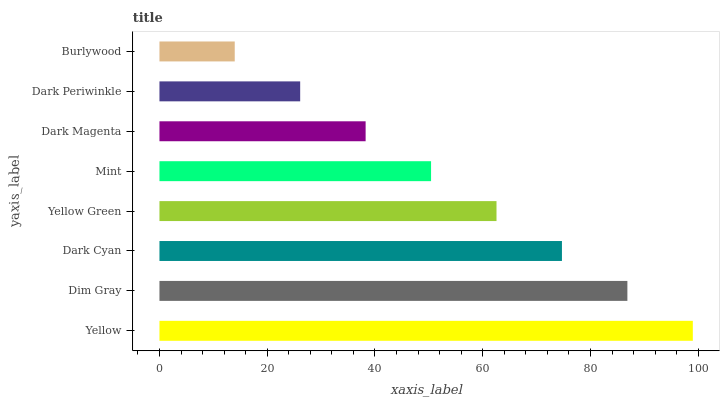Is Burlywood the minimum?
Answer yes or no. Yes. Is Yellow the maximum?
Answer yes or no. Yes. Is Dim Gray the minimum?
Answer yes or no. No. Is Dim Gray the maximum?
Answer yes or no. No. Is Yellow greater than Dim Gray?
Answer yes or no. Yes. Is Dim Gray less than Yellow?
Answer yes or no. Yes. Is Dim Gray greater than Yellow?
Answer yes or no. No. Is Yellow less than Dim Gray?
Answer yes or no. No. Is Yellow Green the high median?
Answer yes or no. Yes. Is Mint the low median?
Answer yes or no. Yes. Is Dim Gray the high median?
Answer yes or no. No. Is Burlywood the low median?
Answer yes or no. No. 